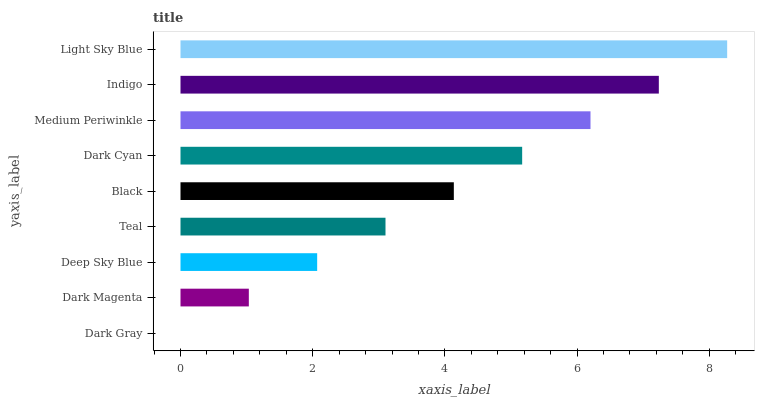Is Dark Gray the minimum?
Answer yes or no. Yes. Is Light Sky Blue the maximum?
Answer yes or no. Yes. Is Dark Magenta the minimum?
Answer yes or no. No. Is Dark Magenta the maximum?
Answer yes or no. No. Is Dark Magenta greater than Dark Gray?
Answer yes or no. Yes. Is Dark Gray less than Dark Magenta?
Answer yes or no. Yes. Is Dark Gray greater than Dark Magenta?
Answer yes or no. No. Is Dark Magenta less than Dark Gray?
Answer yes or no. No. Is Black the high median?
Answer yes or no. Yes. Is Black the low median?
Answer yes or no. Yes. Is Indigo the high median?
Answer yes or no. No. Is Indigo the low median?
Answer yes or no. No. 